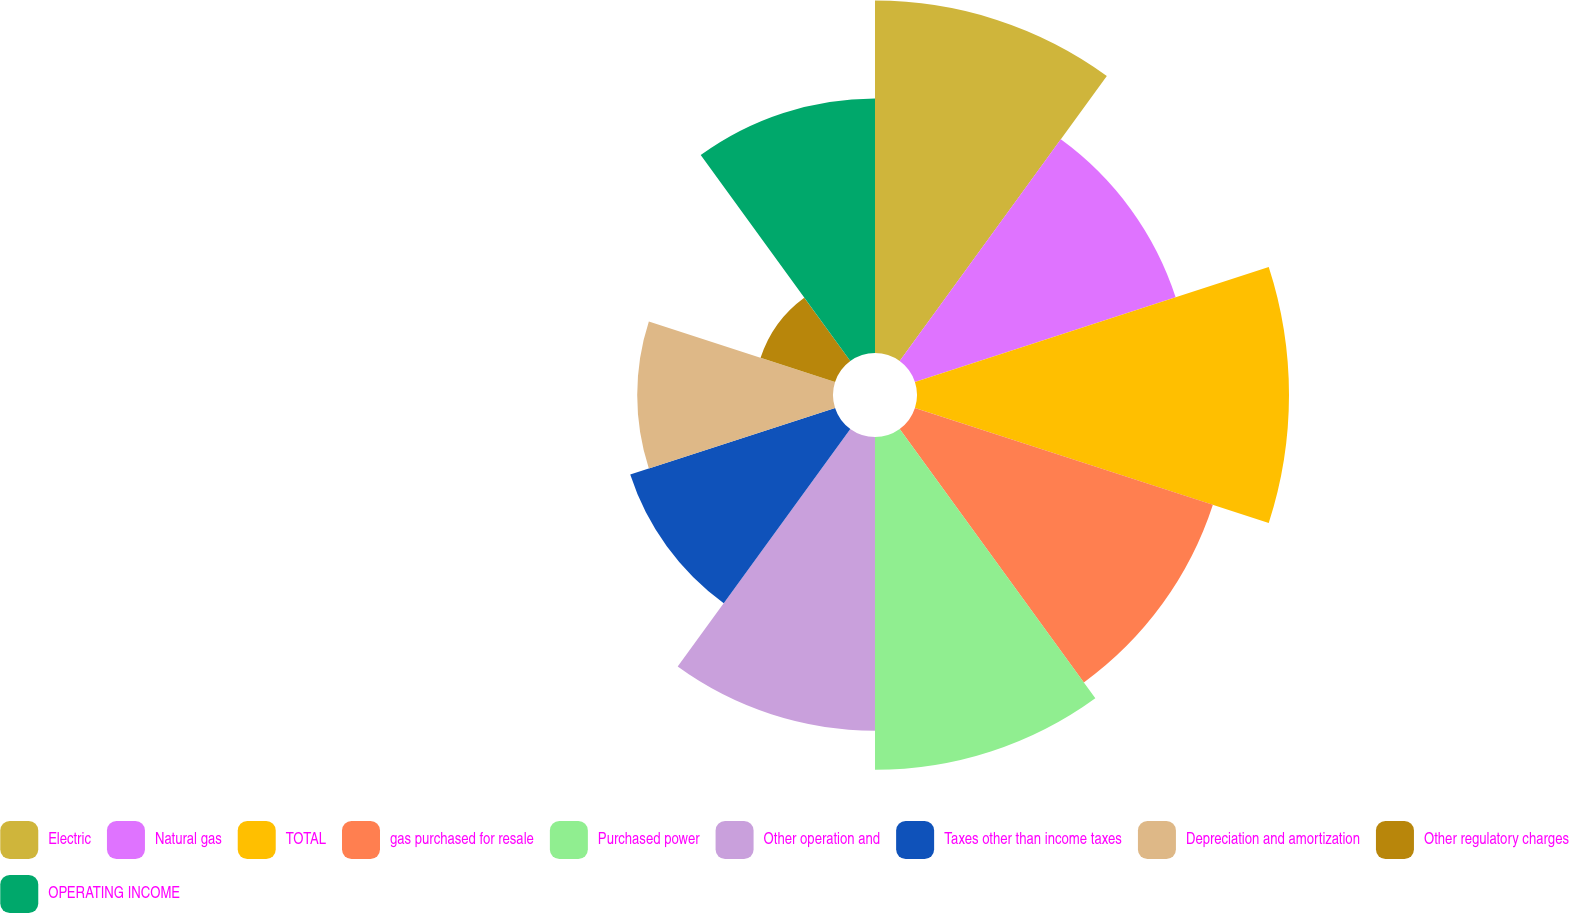<chart> <loc_0><loc_0><loc_500><loc_500><pie_chart><fcel>Electric<fcel>Natural gas<fcel>TOTAL<fcel>gas purchased for resale<fcel>Purchased power<fcel>Other operation and<fcel>Taxes other than income taxes<fcel>Depreciation and amortization<fcel>Other regulatory charges<fcel>OPERATING INCOME<nl><fcel>13.14%<fcel>10.22%<fcel>13.87%<fcel>11.68%<fcel>12.41%<fcel>10.95%<fcel>8.03%<fcel>7.3%<fcel>2.92%<fcel>9.49%<nl></chart> 